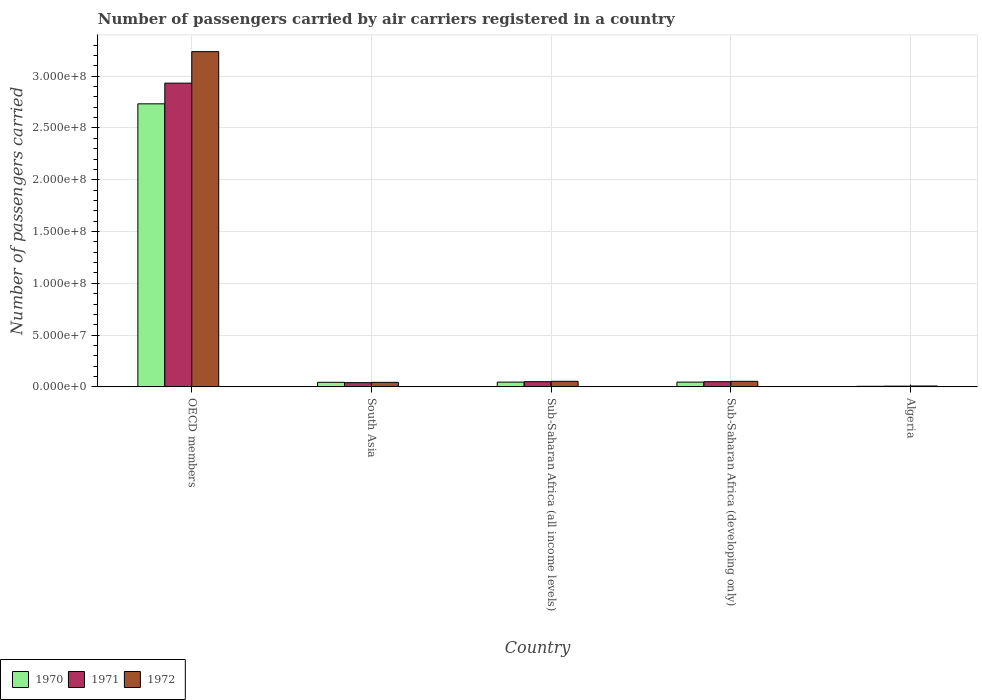How many different coloured bars are there?
Your answer should be very brief. 3. Are the number of bars per tick equal to the number of legend labels?
Provide a succinct answer. Yes. Are the number of bars on each tick of the X-axis equal?
Provide a short and direct response. Yes. How many bars are there on the 3rd tick from the right?
Offer a terse response. 3. What is the label of the 5th group of bars from the left?
Provide a short and direct response. Algeria. In how many cases, is the number of bars for a given country not equal to the number of legend labels?
Give a very brief answer. 0. What is the number of passengers carried by air carriers in 1970 in OECD members?
Provide a succinct answer. 2.73e+08. Across all countries, what is the maximum number of passengers carried by air carriers in 1970?
Provide a short and direct response. 2.73e+08. Across all countries, what is the minimum number of passengers carried by air carriers in 1970?
Offer a terse response. 5.63e+05. In which country was the number of passengers carried by air carriers in 1971 maximum?
Ensure brevity in your answer.  OECD members. In which country was the number of passengers carried by air carriers in 1971 minimum?
Ensure brevity in your answer.  Algeria. What is the total number of passengers carried by air carriers in 1971 in the graph?
Your answer should be very brief. 3.08e+08. What is the difference between the number of passengers carried by air carriers in 1971 in Sub-Saharan Africa (all income levels) and that in Sub-Saharan Africa (developing only)?
Give a very brief answer. 8500. What is the difference between the number of passengers carried by air carriers in 1972 in OECD members and the number of passengers carried by air carriers in 1971 in Sub-Saharan Africa (all income levels)?
Provide a short and direct response. 3.19e+08. What is the average number of passengers carried by air carriers in 1972 per country?
Provide a short and direct response. 6.79e+07. What is the difference between the number of passengers carried by air carriers of/in 1971 and number of passengers carried by air carriers of/in 1972 in South Asia?
Ensure brevity in your answer.  -2.93e+05. In how many countries, is the number of passengers carried by air carriers in 1972 greater than 30000000?
Make the answer very short. 1. What is the ratio of the number of passengers carried by air carriers in 1971 in OECD members to that in Sub-Saharan Africa (all income levels)?
Provide a succinct answer. 58.5. What is the difference between the highest and the second highest number of passengers carried by air carriers in 1970?
Your answer should be very brief. 2.69e+08. What is the difference between the highest and the lowest number of passengers carried by air carriers in 1972?
Provide a succinct answer. 3.23e+08. Are all the bars in the graph horizontal?
Your response must be concise. No. Are the values on the major ticks of Y-axis written in scientific E-notation?
Make the answer very short. Yes. Does the graph contain any zero values?
Give a very brief answer. No. Does the graph contain grids?
Provide a short and direct response. Yes. Where does the legend appear in the graph?
Make the answer very short. Bottom left. How many legend labels are there?
Keep it short and to the point. 3. How are the legend labels stacked?
Provide a short and direct response. Horizontal. What is the title of the graph?
Make the answer very short. Number of passengers carried by air carriers registered in a country. Does "1965" appear as one of the legend labels in the graph?
Ensure brevity in your answer.  No. What is the label or title of the X-axis?
Your response must be concise. Country. What is the label or title of the Y-axis?
Make the answer very short. Number of passengers carried. What is the Number of passengers carried in 1970 in OECD members?
Keep it short and to the point. 2.73e+08. What is the Number of passengers carried of 1971 in OECD members?
Make the answer very short. 2.93e+08. What is the Number of passengers carried in 1972 in OECD members?
Ensure brevity in your answer.  3.24e+08. What is the Number of passengers carried in 1970 in South Asia?
Your response must be concise. 4.40e+06. What is the Number of passengers carried in 1971 in South Asia?
Make the answer very short. 4.07e+06. What is the Number of passengers carried of 1972 in South Asia?
Give a very brief answer. 4.36e+06. What is the Number of passengers carried of 1970 in Sub-Saharan Africa (all income levels)?
Your answer should be very brief. 4.59e+06. What is the Number of passengers carried of 1971 in Sub-Saharan Africa (all income levels)?
Your response must be concise. 5.01e+06. What is the Number of passengers carried of 1972 in Sub-Saharan Africa (all income levels)?
Your response must be concise. 5.36e+06. What is the Number of passengers carried in 1970 in Sub-Saharan Africa (developing only)?
Your answer should be very brief. 4.59e+06. What is the Number of passengers carried of 1971 in Sub-Saharan Africa (developing only)?
Your answer should be very brief. 5.00e+06. What is the Number of passengers carried of 1972 in Sub-Saharan Africa (developing only)?
Offer a terse response. 5.35e+06. What is the Number of passengers carried of 1970 in Algeria?
Provide a short and direct response. 5.63e+05. What is the Number of passengers carried in 1971 in Algeria?
Your answer should be very brief. 7.15e+05. What is the Number of passengers carried in 1972 in Algeria?
Offer a terse response. 8.44e+05. Across all countries, what is the maximum Number of passengers carried in 1970?
Your answer should be very brief. 2.73e+08. Across all countries, what is the maximum Number of passengers carried of 1971?
Offer a very short reply. 2.93e+08. Across all countries, what is the maximum Number of passengers carried in 1972?
Give a very brief answer. 3.24e+08. Across all countries, what is the minimum Number of passengers carried in 1970?
Offer a very short reply. 5.63e+05. Across all countries, what is the minimum Number of passengers carried of 1971?
Make the answer very short. 7.15e+05. Across all countries, what is the minimum Number of passengers carried of 1972?
Give a very brief answer. 8.44e+05. What is the total Number of passengers carried of 1970 in the graph?
Your answer should be very brief. 2.87e+08. What is the total Number of passengers carried of 1971 in the graph?
Your response must be concise. 3.08e+08. What is the total Number of passengers carried of 1972 in the graph?
Make the answer very short. 3.40e+08. What is the difference between the Number of passengers carried in 1970 in OECD members and that in South Asia?
Your answer should be very brief. 2.69e+08. What is the difference between the Number of passengers carried in 1971 in OECD members and that in South Asia?
Provide a short and direct response. 2.89e+08. What is the difference between the Number of passengers carried in 1972 in OECD members and that in South Asia?
Provide a short and direct response. 3.19e+08. What is the difference between the Number of passengers carried in 1970 in OECD members and that in Sub-Saharan Africa (all income levels)?
Provide a succinct answer. 2.69e+08. What is the difference between the Number of passengers carried in 1971 in OECD members and that in Sub-Saharan Africa (all income levels)?
Provide a succinct answer. 2.88e+08. What is the difference between the Number of passengers carried of 1972 in OECD members and that in Sub-Saharan Africa (all income levels)?
Make the answer very short. 3.18e+08. What is the difference between the Number of passengers carried of 1970 in OECD members and that in Sub-Saharan Africa (developing only)?
Ensure brevity in your answer.  2.69e+08. What is the difference between the Number of passengers carried of 1971 in OECD members and that in Sub-Saharan Africa (developing only)?
Offer a terse response. 2.88e+08. What is the difference between the Number of passengers carried in 1972 in OECD members and that in Sub-Saharan Africa (developing only)?
Provide a short and direct response. 3.18e+08. What is the difference between the Number of passengers carried in 1970 in OECD members and that in Algeria?
Provide a succinct answer. 2.73e+08. What is the difference between the Number of passengers carried of 1971 in OECD members and that in Algeria?
Ensure brevity in your answer.  2.93e+08. What is the difference between the Number of passengers carried of 1972 in OECD members and that in Algeria?
Offer a terse response. 3.23e+08. What is the difference between the Number of passengers carried in 1970 in South Asia and that in Sub-Saharan Africa (all income levels)?
Offer a terse response. -1.85e+05. What is the difference between the Number of passengers carried in 1971 in South Asia and that in Sub-Saharan Africa (all income levels)?
Provide a succinct answer. -9.42e+05. What is the difference between the Number of passengers carried of 1972 in South Asia and that in Sub-Saharan Africa (all income levels)?
Your answer should be very brief. -9.96e+05. What is the difference between the Number of passengers carried in 1970 in South Asia and that in Sub-Saharan Africa (developing only)?
Your answer should be very brief. -1.85e+05. What is the difference between the Number of passengers carried in 1971 in South Asia and that in Sub-Saharan Africa (developing only)?
Provide a short and direct response. -9.34e+05. What is the difference between the Number of passengers carried of 1972 in South Asia and that in Sub-Saharan Africa (developing only)?
Keep it short and to the point. -9.87e+05. What is the difference between the Number of passengers carried in 1970 in South Asia and that in Algeria?
Your response must be concise. 3.84e+06. What is the difference between the Number of passengers carried of 1971 in South Asia and that in Algeria?
Ensure brevity in your answer.  3.36e+06. What is the difference between the Number of passengers carried in 1972 in South Asia and that in Algeria?
Provide a short and direct response. 3.52e+06. What is the difference between the Number of passengers carried in 1970 in Sub-Saharan Africa (all income levels) and that in Sub-Saharan Africa (developing only)?
Your answer should be compact. 0. What is the difference between the Number of passengers carried in 1971 in Sub-Saharan Africa (all income levels) and that in Sub-Saharan Africa (developing only)?
Your response must be concise. 8500. What is the difference between the Number of passengers carried of 1972 in Sub-Saharan Africa (all income levels) and that in Sub-Saharan Africa (developing only)?
Your response must be concise. 9000. What is the difference between the Number of passengers carried in 1970 in Sub-Saharan Africa (all income levels) and that in Algeria?
Your answer should be compact. 4.02e+06. What is the difference between the Number of passengers carried in 1971 in Sub-Saharan Africa (all income levels) and that in Algeria?
Offer a very short reply. 4.30e+06. What is the difference between the Number of passengers carried in 1972 in Sub-Saharan Africa (all income levels) and that in Algeria?
Your answer should be compact. 4.52e+06. What is the difference between the Number of passengers carried of 1970 in Sub-Saharan Africa (developing only) and that in Algeria?
Keep it short and to the point. 4.02e+06. What is the difference between the Number of passengers carried of 1971 in Sub-Saharan Africa (developing only) and that in Algeria?
Make the answer very short. 4.29e+06. What is the difference between the Number of passengers carried of 1972 in Sub-Saharan Africa (developing only) and that in Algeria?
Make the answer very short. 4.51e+06. What is the difference between the Number of passengers carried in 1970 in OECD members and the Number of passengers carried in 1971 in South Asia?
Your answer should be very brief. 2.69e+08. What is the difference between the Number of passengers carried of 1970 in OECD members and the Number of passengers carried of 1972 in South Asia?
Make the answer very short. 2.69e+08. What is the difference between the Number of passengers carried of 1971 in OECD members and the Number of passengers carried of 1972 in South Asia?
Your response must be concise. 2.89e+08. What is the difference between the Number of passengers carried of 1970 in OECD members and the Number of passengers carried of 1971 in Sub-Saharan Africa (all income levels)?
Ensure brevity in your answer.  2.68e+08. What is the difference between the Number of passengers carried of 1970 in OECD members and the Number of passengers carried of 1972 in Sub-Saharan Africa (all income levels)?
Offer a terse response. 2.68e+08. What is the difference between the Number of passengers carried of 1971 in OECD members and the Number of passengers carried of 1972 in Sub-Saharan Africa (all income levels)?
Your answer should be compact. 2.88e+08. What is the difference between the Number of passengers carried of 1970 in OECD members and the Number of passengers carried of 1971 in Sub-Saharan Africa (developing only)?
Your response must be concise. 2.68e+08. What is the difference between the Number of passengers carried of 1970 in OECD members and the Number of passengers carried of 1972 in Sub-Saharan Africa (developing only)?
Offer a terse response. 2.68e+08. What is the difference between the Number of passengers carried in 1971 in OECD members and the Number of passengers carried in 1972 in Sub-Saharan Africa (developing only)?
Ensure brevity in your answer.  2.88e+08. What is the difference between the Number of passengers carried of 1970 in OECD members and the Number of passengers carried of 1971 in Algeria?
Keep it short and to the point. 2.73e+08. What is the difference between the Number of passengers carried of 1970 in OECD members and the Number of passengers carried of 1972 in Algeria?
Ensure brevity in your answer.  2.72e+08. What is the difference between the Number of passengers carried of 1971 in OECD members and the Number of passengers carried of 1972 in Algeria?
Ensure brevity in your answer.  2.92e+08. What is the difference between the Number of passengers carried of 1970 in South Asia and the Number of passengers carried of 1971 in Sub-Saharan Africa (all income levels)?
Keep it short and to the point. -6.13e+05. What is the difference between the Number of passengers carried in 1970 in South Asia and the Number of passengers carried in 1972 in Sub-Saharan Africa (all income levels)?
Ensure brevity in your answer.  -9.60e+05. What is the difference between the Number of passengers carried in 1971 in South Asia and the Number of passengers carried in 1972 in Sub-Saharan Africa (all income levels)?
Keep it short and to the point. -1.29e+06. What is the difference between the Number of passengers carried in 1970 in South Asia and the Number of passengers carried in 1971 in Sub-Saharan Africa (developing only)?
Your response must be concise. -6.05e+05. What is the difference between the Number of passengers carried of 1970 in South Asia and the Number of passengers carried of 1972 in Sub-Saharan Africa (developing only)?
Your answer should be compact. -9.51e+05. What is the difference between the Number of passengers carried of 1971 in South Asia and the Number of passengers carried of 1972 in Sub-Saharan Africa (developing only)?
Provide a succinct answer. -1.28e+06. What is the difference between the Number of passengers carried of 1970 in South Asia and the Number of passengers carried of 1971 in Algeria?
Offer a terse response. 3.69e+06. What is the difference between the Number of passengers carried of 1970 in South Asia and the Number of passengers carried of 1972 in Algeria?
Your response must be concise. 3.56e+06. What is the difference between the Number of passengers carried in 1971 in South Asia and the Number of passengers carried in 1972 in Algeria?
Keep it short and to the point. 3.23e+06. What is the difference between the Number of passengers carried in 1970 in Sub-Saharan Africa (all income levels) and the Number of passengers carried in 1971 in Sub-Saharan Africa (developing only)?
Keep it short and to the point. -4.20e+05. What is the difference between the Number of passengers carried of 1970 in Sub-Saharan Africa (all income levels) and the Number of passengers carried of 1972 in Sub-Saharan Africa (developing only)?
Provide a short and direct response. -7.66e+05. What is the difference between the Number of passengers carried of 1971 in Sub-Saharan Africa (all income levels) and the Number of passengers carried of 1972 in Sub-Saharan Africa (developing only)?
Offer a terse response. -3.38e+05. What is the difference between the Number of passengers carried of 1970 in Sub-Saharan Africa (all income levels) and the Number of passengers carried of 1971 in Algeria?
Your response must be concise. 3.87e+06. What is the difference between the Number of passengers carried of 1970 in Sub-Saharan Africa (all income levels) and the Number of passengers carried of 1972 in Algeria?
Offer a very short reply. 3.74e+06. What is the difference between the Number of passengers carried in 1971 in Sub-Saharan Africa (all income levels) and the Number of passengers carried in 1972 in Algeria?
Provide a short and direct response. 4.17e+06. What is the difference between the Number of passengers carried of 1970 in Sub-Saharan Africa (developing only) and the Number of passengers carried of 1971 in Algeria?
Provide a succinct answer. 3.87e+06. What is the difference between the Number of passengers carried in 1970 in Sub-Saharan Africa (developing only) and the Number of passengers carried in 1972 in Algeria?
Give a very brief answer. 3.74e+06. What is the difference between the Number of passengers carried in 1971 in Sub-Saharan Africa (developing only) and the Number of passengers carried in 1972 in Algeria?
Provide a short and direct response. 4.16e+06. What is the average Number of passengers carried in 1970 per country?
Offer a terse response. 5.75e+07. What is the average Number of passengers carried in 1971 per country?
Provide a succinct answer. 6.16e+07. What is the average Number of passengers carried in 1972 per country?
Your answer should be compact. 6.79e+07. What is the difference between the Number of passengers carried of 1970 and Number of passengers carried of 1971 in OECD members?
Ensure brevity in your answer.  -2.00e+07. What is the difference between the Number of passengers carried in 1970 and Number of passengers carried in 1972 in OECD members?
Ensure brevity in your answer.  -5.04e+07. What is the difference between the Number of passengers carried of 1971 and Number of passengers carried of 1972 in OECD members?
Your response must be concise. -3.04e+07. What is the difference between the Number of passengers carried of 1970 and Number of passengers carried of 1971 in South Asia?
Your answer should be very brief. 3.29e+05. What is the difference between the Number of passengers carried in 1970 and Number of passengers carried in 1972 in South Asia?
Keep it short and to the point. 3.63e+04. What is the difference between the Number of passengers carried of 1971 and Number of passengers carried of 1972 in South Asia?
Provide a succinct answer. -2.93e+05. What is the difference between the Number of passengers carried in 1970 and Number of passengers carried in 1971 in Sub-Saharan Africa (all income levels)?
Make the answer very short. -4.28e+05. What is the difference between the Number of passengers carried in 1970 and Number of passengers carried in 1972 in Sub-Saharan Africa (all income levels)?
Keep it short and to the point. -7.75e+05. What is the difference between the Number of passengers carried in 1971 and Number of passengers carried in 1972 in Sub-Saharan Africa (all income levels)?
Your answer should be very brief. -3.47e+05. What is the difference between the Number of passengers carried in 1970 and Number of passengers carried in 1971 in Sub-Saharan Africa (developing only)?
Provide a succinct answer. -4.20e+05. What is the difference between the Number of passengers carried of 1970 and Number of passengers carried of 1972 in Sub-Saharan Africa (developing only)?
Make the answer very short. -7.66e+05. What is the difference between the Number of passengers carried of 1971 and Number of passengers carried of 1972 in Sub-Saharan Africa (developing only)?
Make the answer very short. -3.46e+05. What is the difference between the Number of passengers carried of 1970 and Number of passengers carried of 1971 in Algeria?
Provide a succinct answer. -1.52e+05. What is the difference between the Number of passengers carried of 1970 and Number of passengers carried of 1972 in Algeria?
Offer a very short reply. -2.81e+05. What is the difference between the Number of passengers carried in 1971 and Number of passengers carried in 1972 in Algeria?
Keep it short and to the point. -1.29e+05. What is the ratio of the Number of passengers carried of 1970 in OECD members to that in South Asia?
Give a very brief answer. 62.12. What is the ratio of the Number of passengers carried of 1971 in OECD members to that in South Asia?
Give a very brief answer. 72.05. What is the ratio of the Number of passengers carried in 1972 in OECD members to that in South Asia?
Offer a very short reply. 74.18. What is the ratio of the Number of passengers carried of 1970 in OECD members to that in Sub-Saharan Africa (all income levels)?
Provide a succinct answer. 59.61. What is the ratio of the Number of passengers carried in 1971 in OECD members to that in Sub-Saharan Africa (all income levels)?
Your response must be concise. 58.5. What is the ratio of the Number of passengers carried in 1972 in OECD members to that in Sub-Saharan Africa (all income levels)?
Offer a very short reply. 60.4. What is the ratio of the Number of passengers carried of 1970 in OECD members to that in Sub-Saharan Africa (developing only)?
Your answer should be very brief. 59.61. What is the ratio of the Number of passengers carried of 1971 in OECD members to that in Sub-Saharan Africa (developing only)?
Your response must be concise. 58.6. What is the ratio of the Number of passengers carried in 1972 in OECD members to that in Sub-Saharan Africa (developing only)?
Ensure brevity in your answer.  60.5. What is the ratio of the Number of passengers carried of 1970 in OECD members to that in Algeria?
Offer a terse response. 485.31. What is the ratio of the Number of passengers carried of 1971 in OECD members to that in Algeria?
Provide a short and direct response. 410.32. What is the ratio of the Number of passengers carried in 1972 in OECD members to that in Algeria?
Offer a terse response. 383.62. What is the ratio of the Number of passengers carried in 1970 in South Asia to that in Sub-Saharan Africa (all income levels)?
Give a very brief answer. 0.96. What is the ratio of the Number of passengers carried of 1971 in South Asia to that in Sub-Saharan Africa (all income levels)?
Make the answer very short. 0.81. What is the ratio of the Number of passengers carried in 1972 in South Asia to that in Sub-Saharan Africa (all income levels)?
Keep it short and to the point. 0.81. What is the ratio of the Number of passengers carried in 1970 in South Asia to that in Sub-Saharan Africa (developing only)?
Your response must be concise. 0.96. What is the ratio of the Number of passengers carried in 1971 in South Asia to that in Sub-Saharan Africa (developing only)?
Your answer should be very brief. 0.81. What is the ratio of the Number of passengers carried in 1972 in South Asia to that in Sub-Saharan Africa (developing only)?
Your answer should be compact. 0.82. What is the ratio of the Number of passengers carried in 1970 in South Asia to that in Algeria?
Your response must be concise. 7.81. What is the ratio of the Number of passengers carried in 1971 in South Asia to that in Algeria?
Your answer should be compact. 5.7. What is the ratio of the Number of passengers carried in 1972 in South Asia to that in Algeria?
Provide a succinct answer. 5.17. What is the ratio of the Number of passengers carried of 1970 in Sub-Saharan Africa (all income levels) to that in Sub-Saharan Africa (developing only)?
Give a very brief answer. 1. What is the ratio of the Number of passengers carried of 1971 in Sub-Saharan Africa (all income levels) to that in Sub-Saharan Africa (developing only)?
Your answer should be compact. 1. What is the ratio of the Number of passengers carried of 1972 in Sub-Saharan Africa (all income levels) to that in Sub-Saharan Africa (developing only)?
Ensure brevity in your answer.  1. What is the ratio of the Number of passengers carried of 1970 in Sub-Saharan Africa (all income levels) to that in Algeria?
Offer a very short reply. 8.14. What is the ratio of the Number of passengers carried in 1971 in Sub-Saharan Africa (all income levels) to that in Algeria?
Give a very brief answer. 7.01. What is the ratio of the Number of passengers carried in 1972 in Sub-Saharan Africa (all income levels) to that in Algeria?
Provide a short and direct response. 6.35. What is the ratio of the Number of passengers carried in 1970 in Sub-Saharan Africa (developing only) to that in Algeria?
Provide a succinct answer. 8.14. What is the ratio of the Number of passengers carried of 1971 in Sub-Saharan Africa (developing only) to that in Algeria?
Your answer should be compact. 7. What is the ratio of the Number of passengers carried of 1972 in Sub-Saharan Africa (developing only) to that in Algeria?
Keep it short and to the point. 6.34. What is the difference between the highest and the second highest Number of passengers carried of 1970?
Your answer should be very brief. 2.69e+08. What is the difference between the highest and the second highest Number of passengers carried in 1971?
Provide a short and direct response. 2.88e+08. What is the difference between the highest and the second highest Number of passengers carried in 1972?
Your response must be concise. 3.18e+08. What is the difference between the highest and the lowest Number of passengers carried of 1970?
Provide a short and direct response. 2.73e+08. What is the difference between the highest and the lowest Number of passengers carried in 1971?
Ensure brevity in your answer.  2.93e+08. What is the difference between the highest and the lowest Number of passengers carried of 1972?
Give a very brief answer. 3.23e+08. 